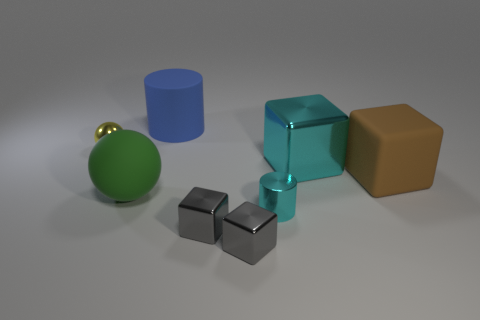Is there a big shiny object that has the same shape as the blue matte thing?
Provide a short and direct response. No. What is the material of the blue object that is the same size as the green thing?
Ensure brevity in your answer.  Rubber. There is a rubber object that is to the right of the small cyan metallic thing; what is its size?
Provide a short and direct response. Large. There is a metallic object left of the rubber ball; does it have the same size as the cyan metallic object in front of the green thing?
Provide a succinct answer. Yes. What number of large brown objects are the same material as the large ball?
Your answer should be very brief. 1. The large cylinder is what color?
Give a very brief answer. Blue. Are there any large things behind the matte ball?
Ensure brevity in your answer.  Yes. Does the shiny sphere have the same color as the large rubber block?
Offer a very short reply. No. What number of tiny cylinders are the same color as the big metal block?
Offer a very short reply. 1. There is a brown cube in front of the shiny thing that is left of the green object; what size is it?
Provide a short and direct response. Large. 